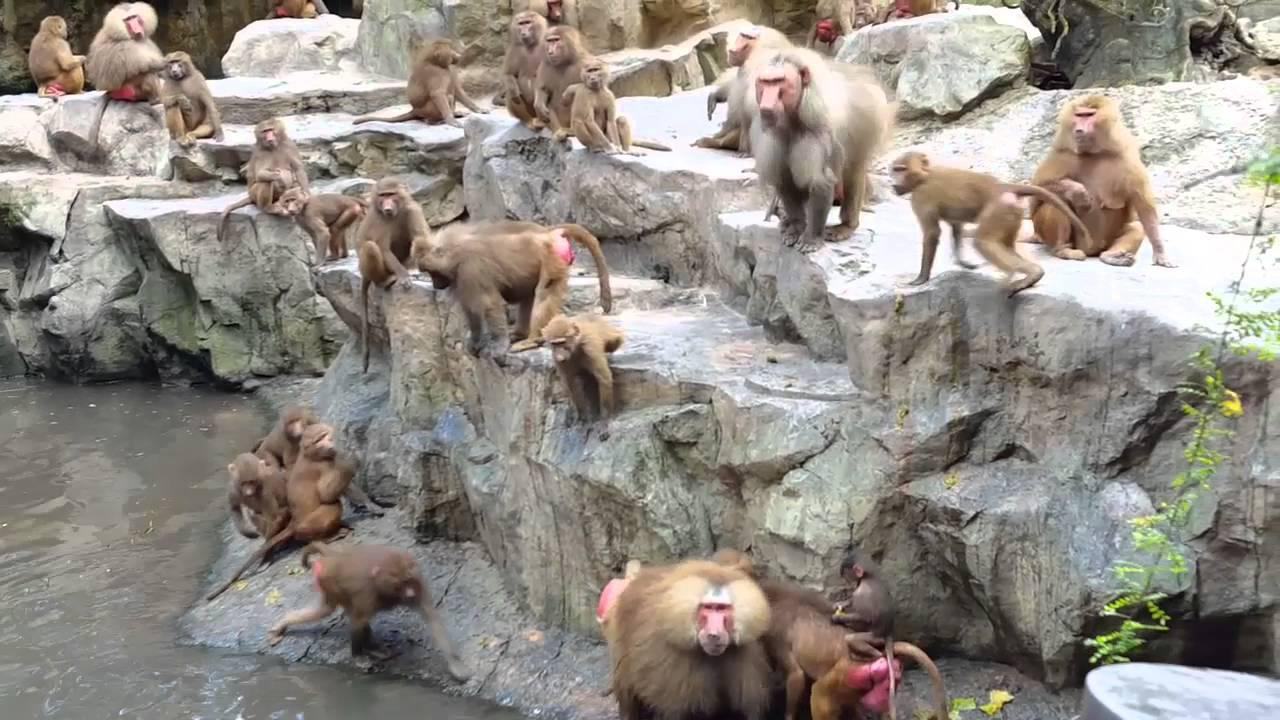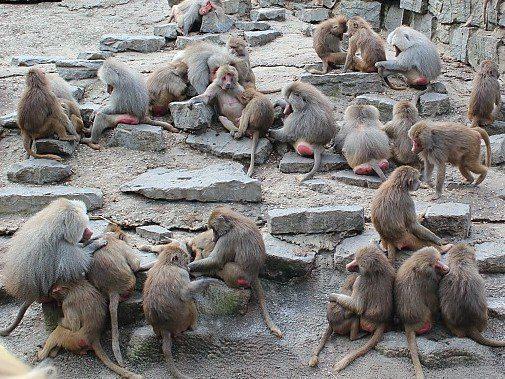The first image is the image on the left, the second image is the image on the right. Evaluate the accuracy of this statement regarding the images: "Multiple baboons sit on tiered rocks in at least one image.". Is it true? Answer yes or no. Yes. The first image is the image on the left, the second image is the image on the right. Evaluate the accuracy of this statement regarding the images: "One of the images contains no more than five monkeys". Is it true? Answer yes or no. No. 